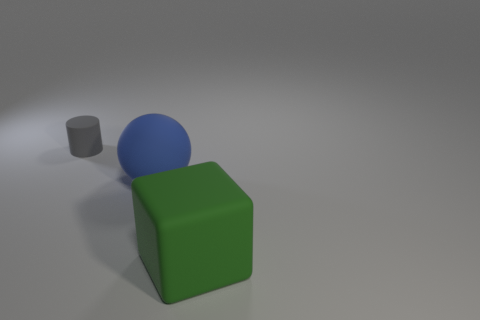Add 1 matte spheres. How many objects exist? 4 Subtract all balls. How many objects are left? 2 Add 2 gray cylinders. How many gray cylinders are left? 3 Add 3 small blue matte blocks. How many small blue matte blocks exist? 3 Subtract 0 brown balls. How many objects are left? 3 Subtract all large rubber spheres. Subtract all blue objects. How many objects are left? 1 